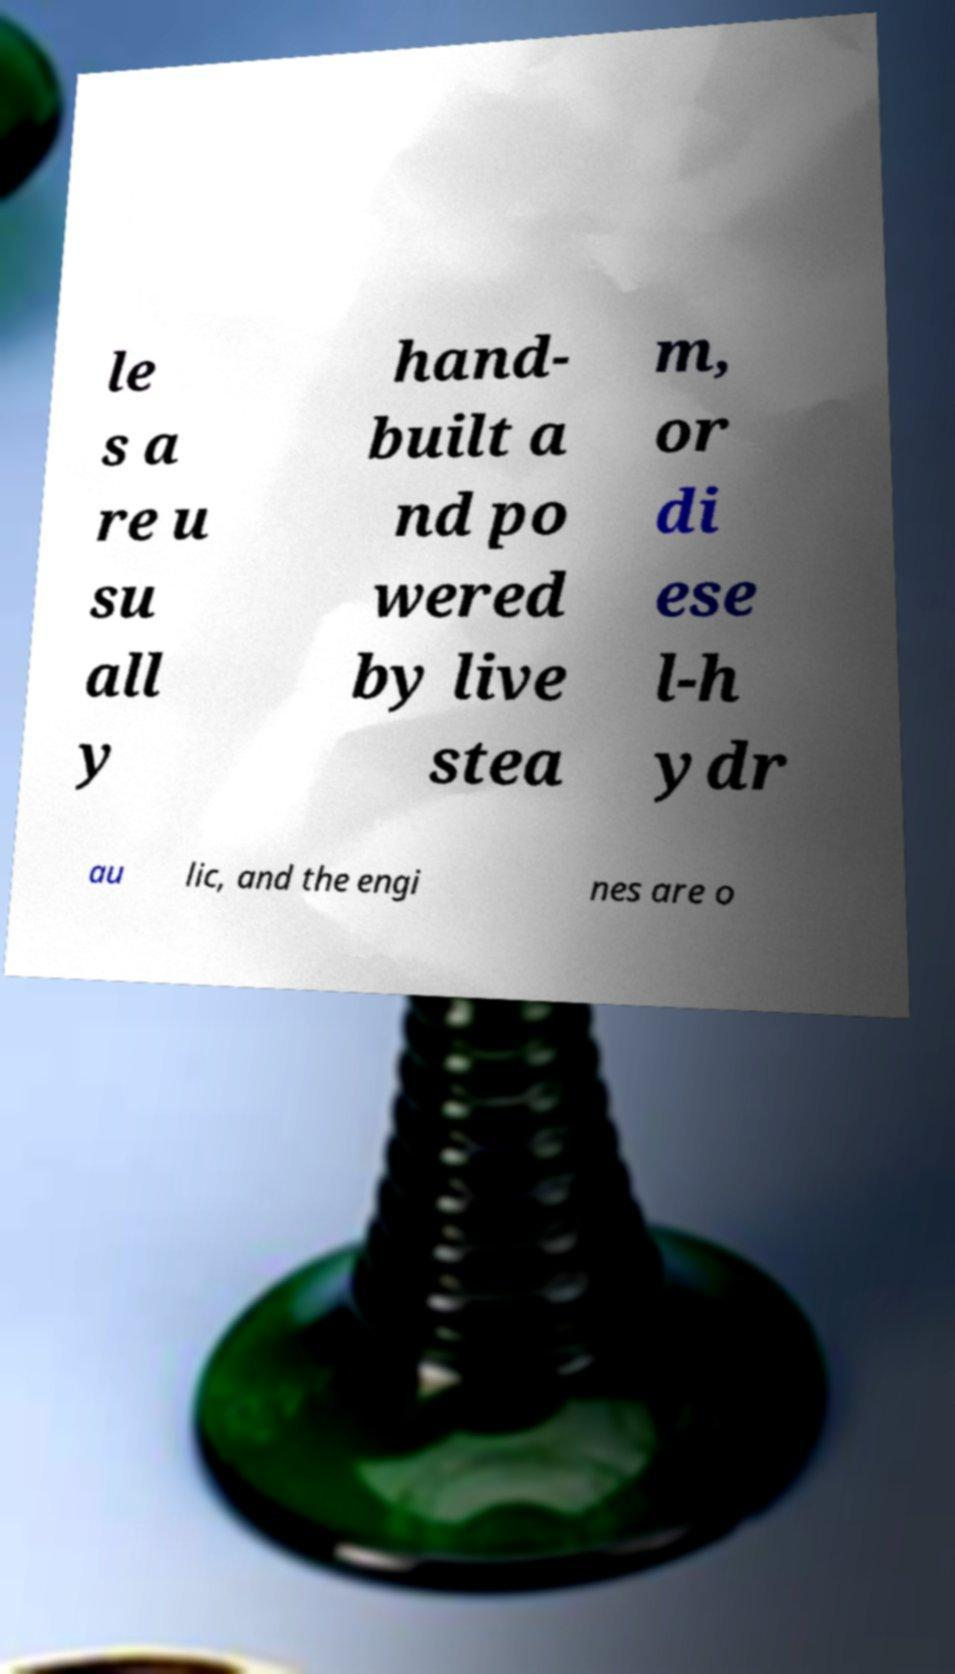Please read and relay the text visible in this image. What does it say? le s a re u su all y hand- built a nd po wered by live stea m, or di ese l-h ydr au lic, and the engi nes are o 